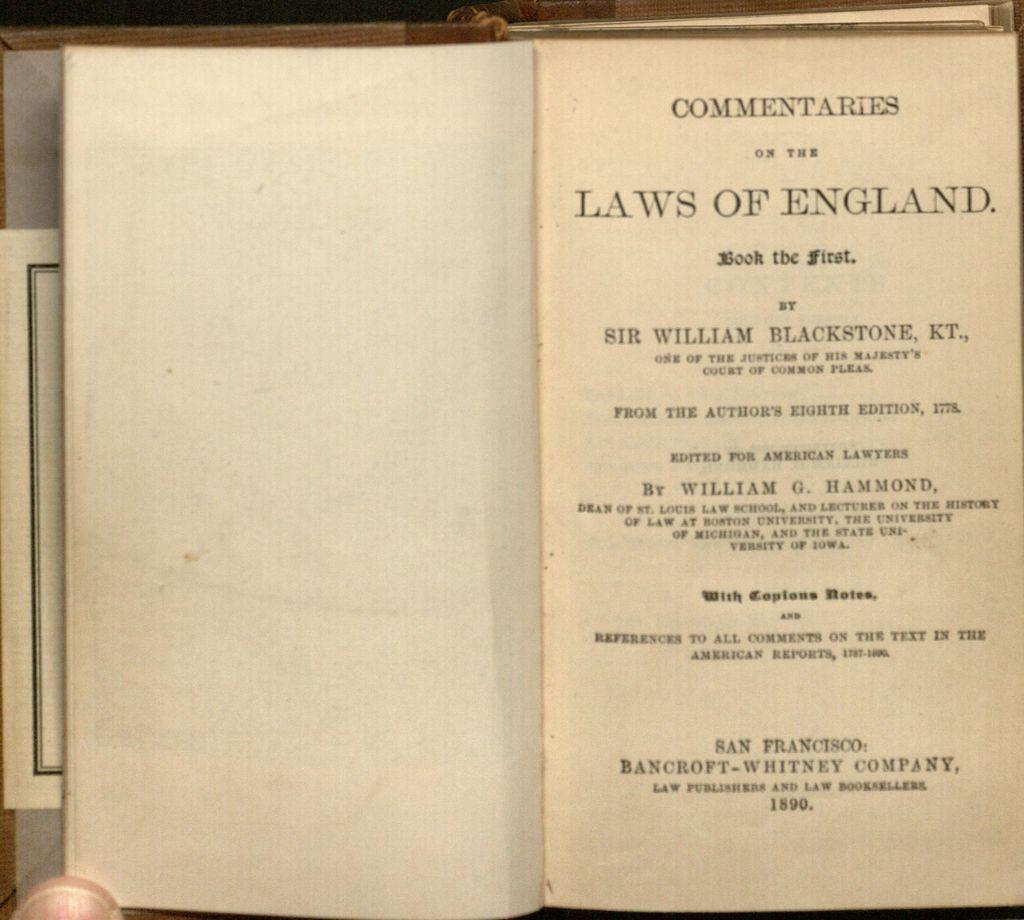What is the main object in the foreground of the picture? There is a book in the foreground of the picture. What is the state of the book in the image? The book is opened. Can you describe the content of the book? Text is printed on one side of the book. Whose thumb can be seen at the bottom of the book? The thumb of a person is visible at the bottom of the book. How many girls are visible in the image? There is no girl present in the image; it only features a book with a visible thumb. What level of difficulty is the book designed for? The level of difficulty cannot be determined from the image, as it only shows a book with text and a thumb. 